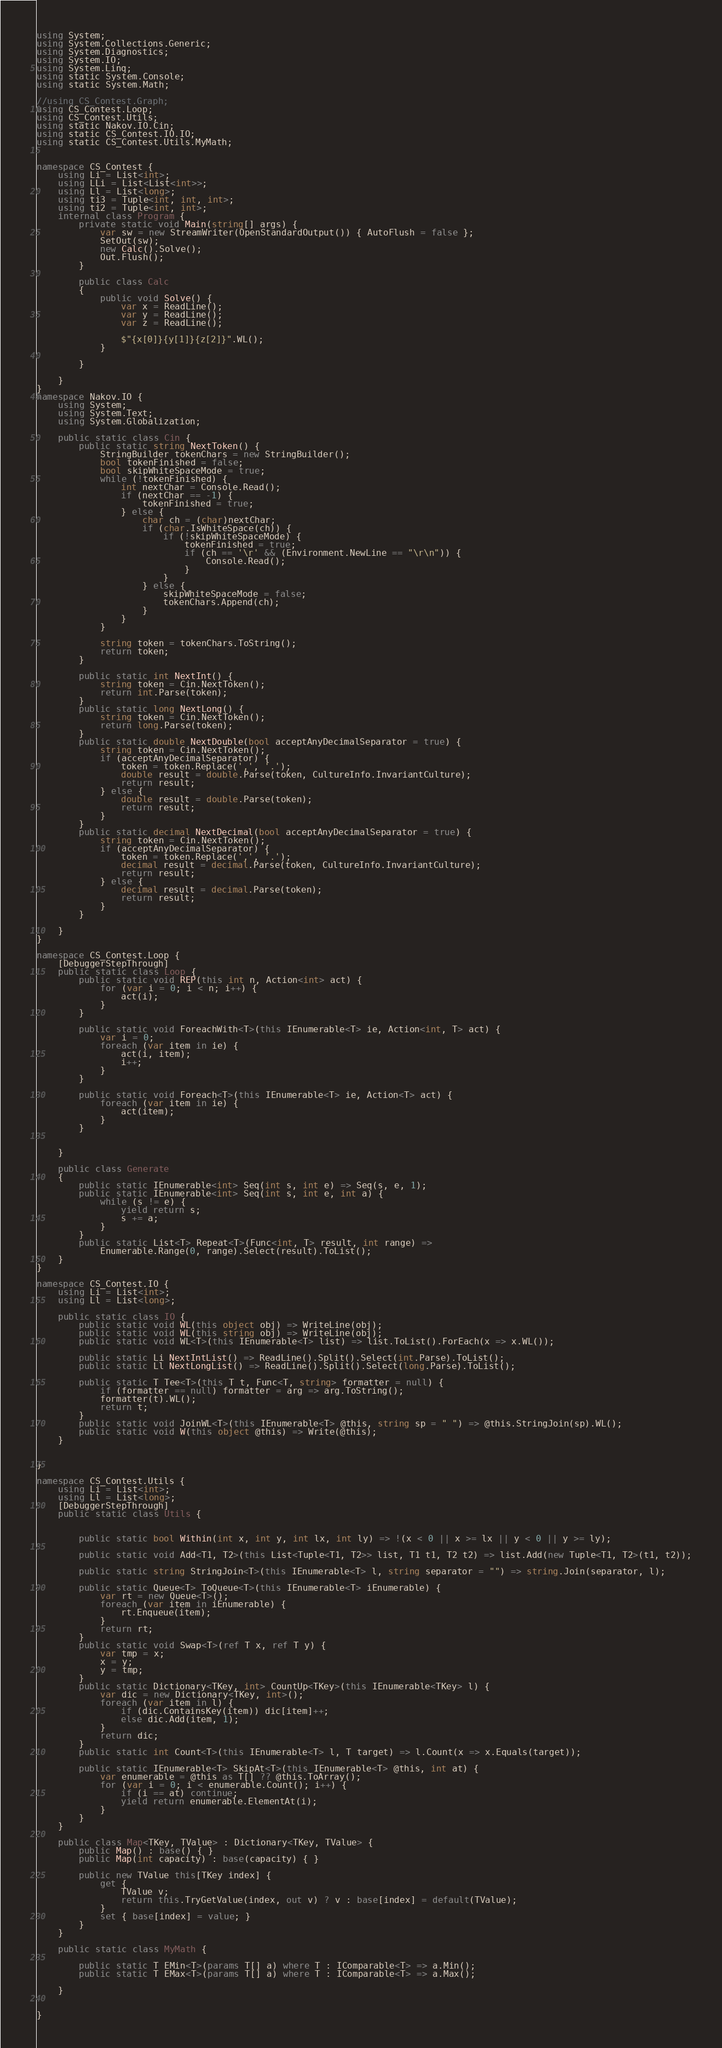Convert code to text. <code><loc_0><loc_0><loc_500><loc_500><_C#_>using System;
using System.Collections.Generic;
using System.Diagnostics;
using System.IO;
using System.Linq;
using static System.Console;
using static System.Math;

//using CS_Contest.Graph;
using CS_Contest.Loop;
using CS_Contest.Utils;
using static Nakov.IO.Cin;
using static CS_Contest.IO.IO;
using static CS_Contest.Utils.MyMath;


namespace CS_Contest {
	using Li = List<int>;
	using LLi = List<List<int>>;
	using Ll = List<long>;
	using ti3 = Tuple<int, int, int>;
	using ti2 = Tuple<int, int>;
	internal class Program {
		private static void Main(string[] args) {
			var sw = new StreamWriter(OpenStandardOutput()) { AutoFlush = false };
			SetOut(sw);
			new Calc().Solve();
			Out.Flush();
		}

		public class Calc
		{
			public void Solve() {
				var x = ReadLine();
				var y = ReadLine();
				var z = ReadLine();

				$"{x[0]}{y[1]}{z[2]}".WL();
			}
			
		}
		
	}
}
namespace Nakov.IO {
	using System;
	using System.Text;
	using System.Globalization;

	public static class Cin {
		public static string NextToken() {
			StringBuilder tokenChars = new StringBuilder();
			bool tokenFinished = false;
			bool skipWhiteSpaceMode = true;
			while (!tokenFinished) {
				int nextChar = Console.Read();
				if (nextChar == -1) {
					tokenFinished = true;
				} else {
					char ch = (char)nextChar;
					if (char.IsWhiteSpace(ch)) {
						if (!skipWhiteSpaceMode) {
							tokenFinished = true;
							if (ch == '\r' && (Environment.NewLine == "\r\n")) {
								Console.Read();
							}
						}
					} else {
						skipWhiteSpaceMode = false;
						tokenChars.Append(ch);
					}
				}
			}

			string token = tokenChars.ToString();
			return token;
		}

		public static int NextInt() {
			string token = Cin.NextToken();
			return int.Parse(token);
		}
		public static long NextLong() {
			string token = Cin.NextToken();
			return long.Parse(token);
		}
		public static double NextDouble(bool acceptAnyDecimalSeparator = true) {
			string token = Cin.NextToken();
			if (acceptAnyDecimalSeparator) {
				token = token.Replace(',', '.');
				double result = double.Parse(token, CultureInfo.InvariantCulture);
				return result;
			} else {
				double result = double.Parse(token);
				return result;
			}
		}
		public static decimal NextDecimal(bool acceptAnyDecimalSeparator = true) {
			string token = Cin.NextToken();
			if (acceptAnyDecimalSeparator) {
				token = token.Replace(',', '.');
				decimal result = decimal.Parse(token, CultureInfo.InvariantCulture);
				return result;
			} else {
				decimal result = decimal.Parse(token);
				return result;
			}
		}

	}
}

namespace CS_Contest.Loop {
	[DebuggerStepThrough]
	public static class Loop {
		public static void REP(this int n, Action<int> act) {
			for (var i = 0; i < n; i++) {
				act(i);
			}
		}

		public static void ForeachWith<T>(this IEnumerable<T> ie, Action<int, T> act) {
			var i = 0;
			foreach (var item in ie) {
				act(i, item);
				i++;
			}
		}

		public static void Foreach<T>(this IEnumerable<T> ie, Action<T> act) {
			foreach (var item in ie) {
				act(item);
			}
		}

		
	}

	public class Generate
	{
		public static IEnumerable<int> Seq(int s, int e) => Seq(s, e, 1);
		public static IEnumerable<int> Seq(int s, int e, int a) {
			while (s != e) {
				yield return s;
				s += a;
			}
		}
		public static List<T> Repeat<T>(Func<int, T> result, int range) =>
			Enumerable.Range(0, range).Select(result).ToList();
	}
}

namespace CS_Contest.IO {
	using Li = List<int>;
	using Ll = List<long>;

	public static class IO {
		public static void WL(this object obj) => WriteLine(obj);
		public static void WL(this string obj) => WriteLine(obj);
		public static void WL<T>(this IEnumerable<T> list) => list.ToList().ForEach(x => x.WL());

		public static Li NextIntList() => ReadLine().Split().Select(int.Parse).ToList();
		public static Ll NextLongList() => ReadLine().Split().Select(long.Parse).ToList();

		public static T Tee<T>(this T t, Func<T, string> formatter = null) {
			if (formatter == null) formatter = arg => arg.ToString();
			formatter(t).WL();
			return t;
		}
		public static void JoinWL<T>(this IEnumerable<T> @this, string sp = " ") => @this.StringJoin(sp).WL();
		public static void W(this object @this) => Write(@this);
	}


}

namespace CS_Contest.Utils {
	using Li = List<int>;
	using Ll = List<long>;
	[DebuggerStepThrough]
	public static class Utils {
		

		public static bool Within(int x, int y, int lx, int ly) => !(x < 0 || x >= lx || y < 0 || y >= ly);

		public static void Add<T1, T2>(this List<Tuple<T1, T2>> list, T1 t1, T2 t2) => list.Add(new Tuple<T1, T2>(t1, t2));

		public static string StringJoin<T>(this IEnumerable<T> l, string separator = "") => string.Join(separator, l);

		public static Queue<T> ToQueue<T>(this IEnumerable<T> iEnumerable) {
			var rt = new Queue<T>();
			foreach (var item in iEnumerable) {
				rt.Enqueue(item);
			}
			return rt;
		}
		public static void Swap<T>(ref T x, ref T y) {
			var tmp = x;
			x = y;
			y = tmp;
		}
		public static Dictionary<TKey, int> CountUp<TKey>(this IEnumerable<TKey> l) {
			var dic = new Dictionary<TKey, int>();
			foreach (var item in l) {
				if (dic.ContainsKey(item)) dic[item]++;
				else dic.Add(item, 1);
			}
			return dic;
		}
		public static int Count<T>(this IEnumerable<T> l, T target) => l.Count(x => x.Equals(target));

		public static IEnumerable<T> SkipAt<T>(this IEnumerable<T> @this, int at) {
			var enumerable = @this as T[] ?? @this.ToArray();
			for (var i = 0; i < enumerable.Count(); i++) {
				if (i == at) continue;
				yield return enumerable.ElementAt(i);
			}
		}
	}

	public class Map<TKey, TValue> : Dictionary<TKey, TValue> {
		public Map() : base() { }
		public Map(int capacity) : base(capacity) { }

		public new TValue this[TKey index] {
			get {
				TValue v;
				return this.TryGetValue(index, out v) ? v : base[index] = default(TValue);
			}
			set { base[index] = value; }
		}
	}

	public static class MyMath {
		
		public static T EMin<T>(params T[] a) where T : IComparable<T> => a.Min();
		public static T EMax<T>(params T[] a) where T : IComparable<T> => a.Max();

	}


}

</code> 